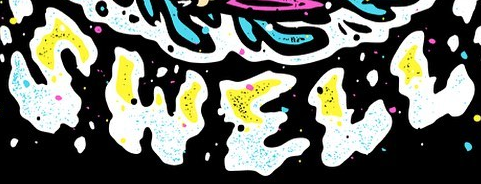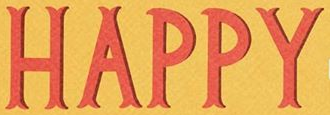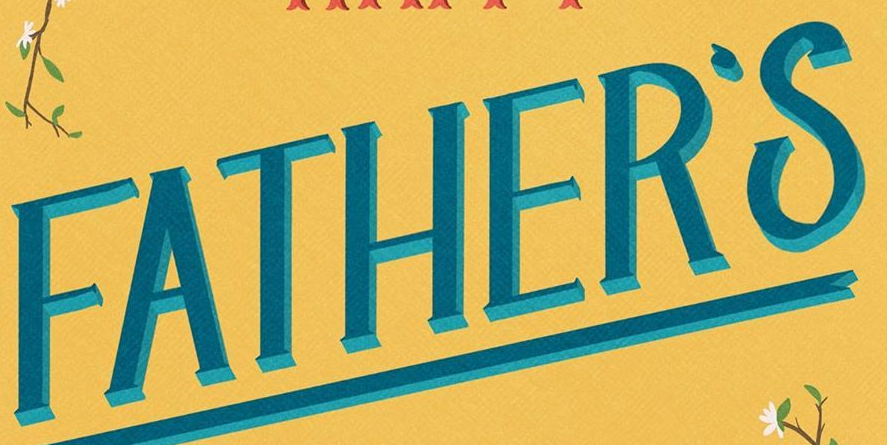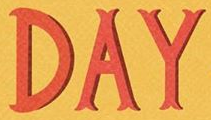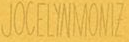Transcribe the words shown in these images in order, separated by a semicolon. SWELL; HAPPY; FATHER'S; DAY; JOCELYNMONIZ 